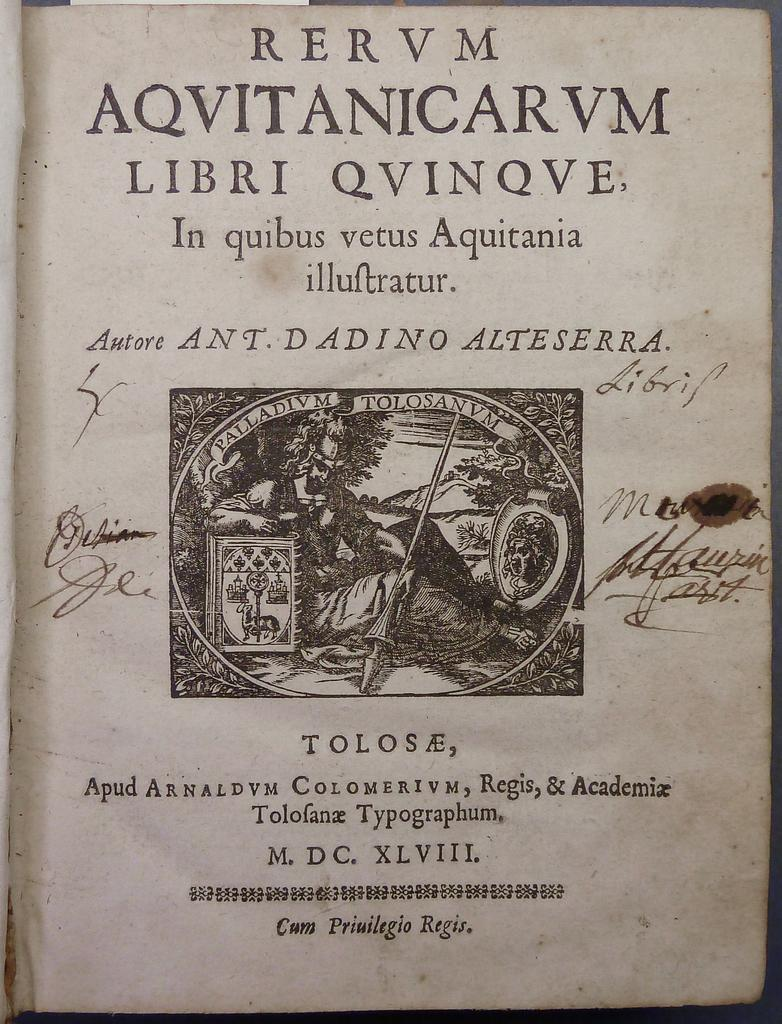Provide a one-sentence caption for the provided image. A page from an ancient book showing RERUM written in Latin on the very top. 